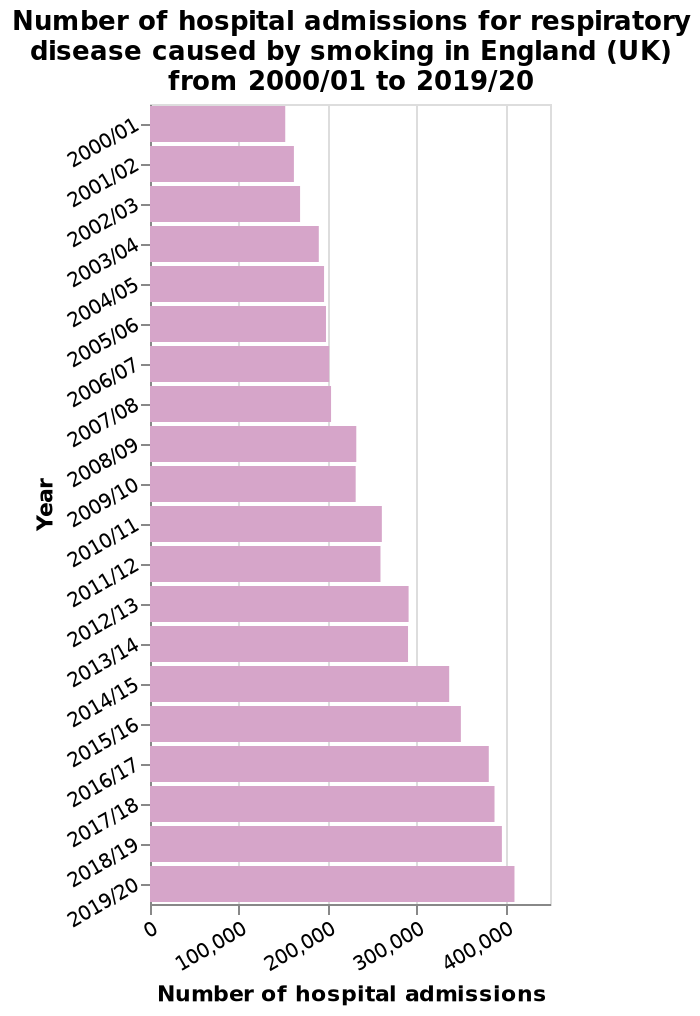<image>
What is the name of the bar chart?  The bar chart is named "Number of hospital admissions for respiratory disease caused by smoking in England (UK) from 2000/01 to 2019/20." What is the duration of the observed increase in hospital admissions?  The increase in hospital admissions is observed from 2006 to 2014. 